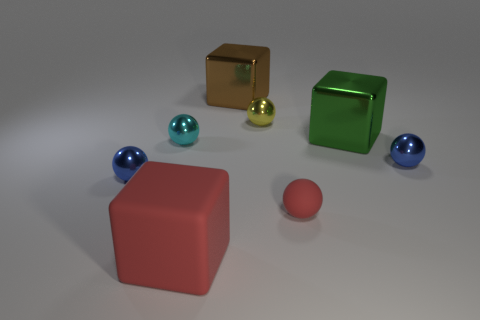Subtract all small cyan spheres. How many spheres are left? 4 Subtract all red spheres. How many spheres are left? 4 Subtract all gray spheres. Subtract all purple cylinders. How many spheres are left? 5 Add 1 big green cylinders. How many objects exist? 9 Subtract all balls. How many objects are left? 3 Subtract 1 green blocks. How many objects are left? 7 Subtract all red rubber things. Subtract all red spheres. How many objects are left? 5 Add 7 large green cubes. How many large green cubes are left? 8 Add 6 green objects. How many green objects exist? 7 